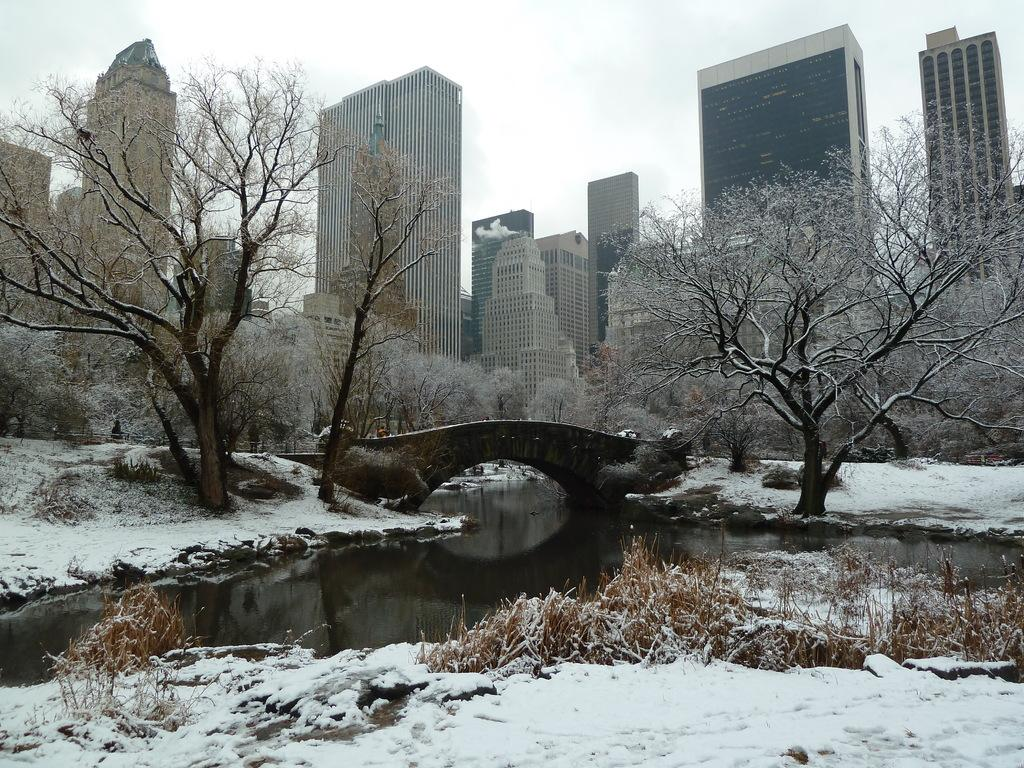What type of weather is depicted in the image? There is snow in the image, indicating a cold or wintry weather condition. What natural element is present in the image? There is water in the image, which could be a river or lake. What man-made structure is visible in the image? There is a bridge in the image, which likely spans across the water. What type of vegetation is present in the image? There are trees in the image, providing a natural backdrop to the scene. What type of urban environment is depicted in the image? There are big buildings in the image, suggesting an urban or city setting. What type of crow can be seen sitting on the book in the image? There is no crow or book present in the image; it features snow, water, a bridge, trees, and big buildings. 